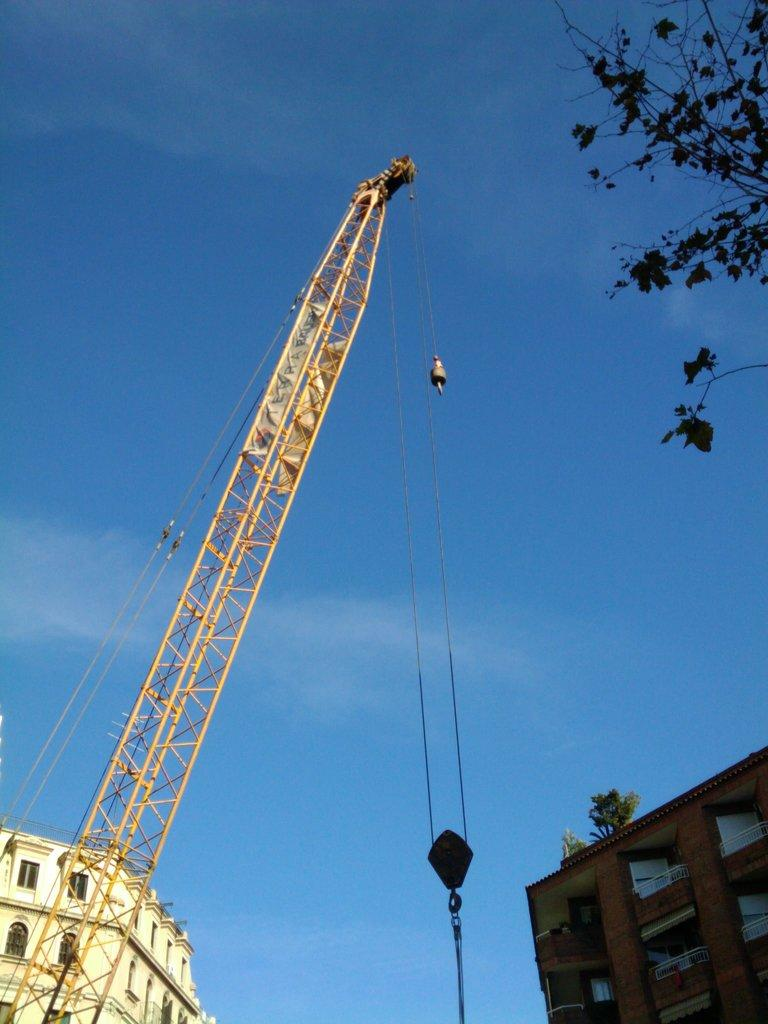What is the main object on the right side of the image? There is a crane on the right side of the image. What is located behind the crane? There is a building behind the crane. Are there any other buildings visible in the image? Yes, there is another building in the background of the image. What color is the sky in the background of the image? The sky is blue in the background of the image. How many ladybugs can be seen crawling on the crane in the image? There are no ladybugs present in the image; it features a crane and buildings. What type of writing can be seen on the side of the crane in the image? There is no writing visible on the crane in the image. 